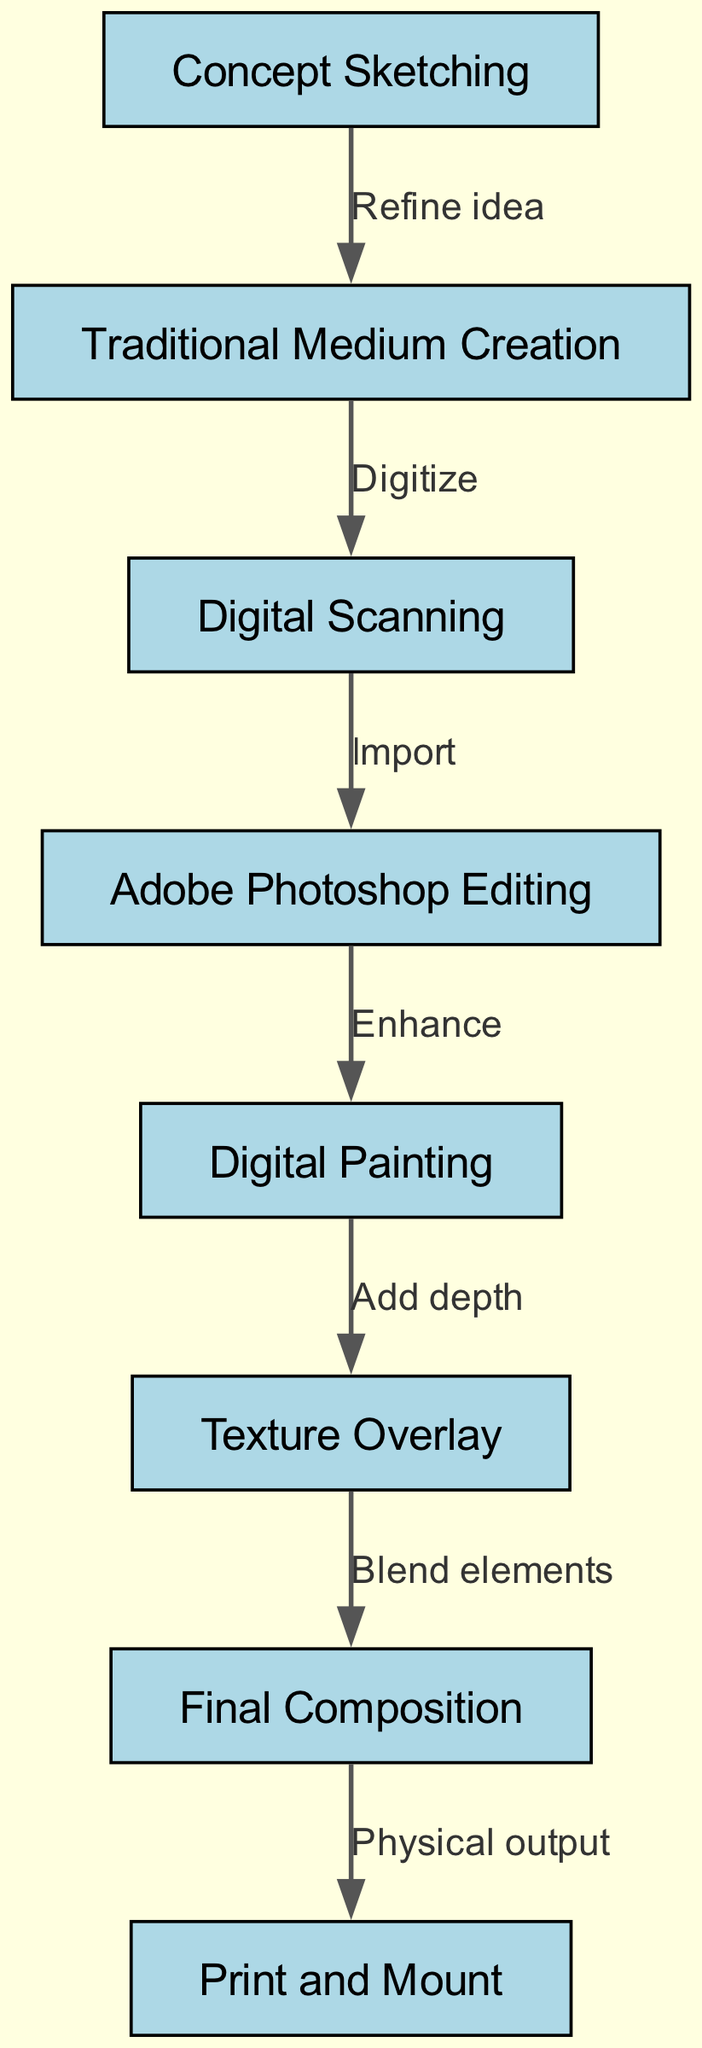What is the first step in the workflow? The first step is indicated as a node labeled "Concept Sketching." It is the first node in the diagram, signaling the starting point of the mixed-media artwork workflow.
Answer: Concept Sketching How many nodes are there in total? By counting the distinct nodes in the diagram, we identify 8 unique nodes, each representing a step in the workflow.
Answer: 8 Which node directly follows "Digital Scanning"? The node that follows "Digital Scanning" is labeled "Adobe Photoshop Editing." The edge leading from "Digital Scanning" to "Adobe Photoshop Editing" signifies the next step in the process.
Answer: Adobe Photoshop Editing What relationship is depicted between "Texture Overlay" and "Final Composition"? The diagram shows an edge labeled "Blend elements" connecting "Texture Overlay" to "Final Composition." This signifies that texture is used to enhance the final composition of the artwork.
Answer: Blend elements Which node involves enhancing the artwork digitally? The node responsible for enhancing the artwork digitally is "Digital Painting." This node is connected to "Adobe Photoshop Editing," indicating that this step involves digital enhancement.
Answer: Digital Painting What is the final step of the workflow? The final step in the workflow is represented by the node labeled "Print and Mount." It indicates the completion of the mixed-media artwork process where the final output is prepared for display.
Answer: Print and Mount Explain the transition from "Traditional Medium Creation" to "Digital Scanning." The transition from "Traditional Medium Creation" to "Digital Scanning" is communicated through an edge labeled "Digitize." This indicates that the artwork created using traditional means is converted into a digital format at this point.
Answer: Digitize How do the elements visually combine before printing? The combination of elements occurs in the node labeled "Final Composition," which follows "Texture Overlay." The label "Blend elements" on the edge signifies the integration of textures and components before physical output.
Answer: Blend elements What is the purpose of "Adobe Photoshop Editing" in the workflow? The purpose is to "Enhance" the artwork, as indicated by the label on the edge connecting "Adobe Photoshop Editing" to "Digital Painting." This step is crucial for refining the digital artwork.
Answer: Enhance 